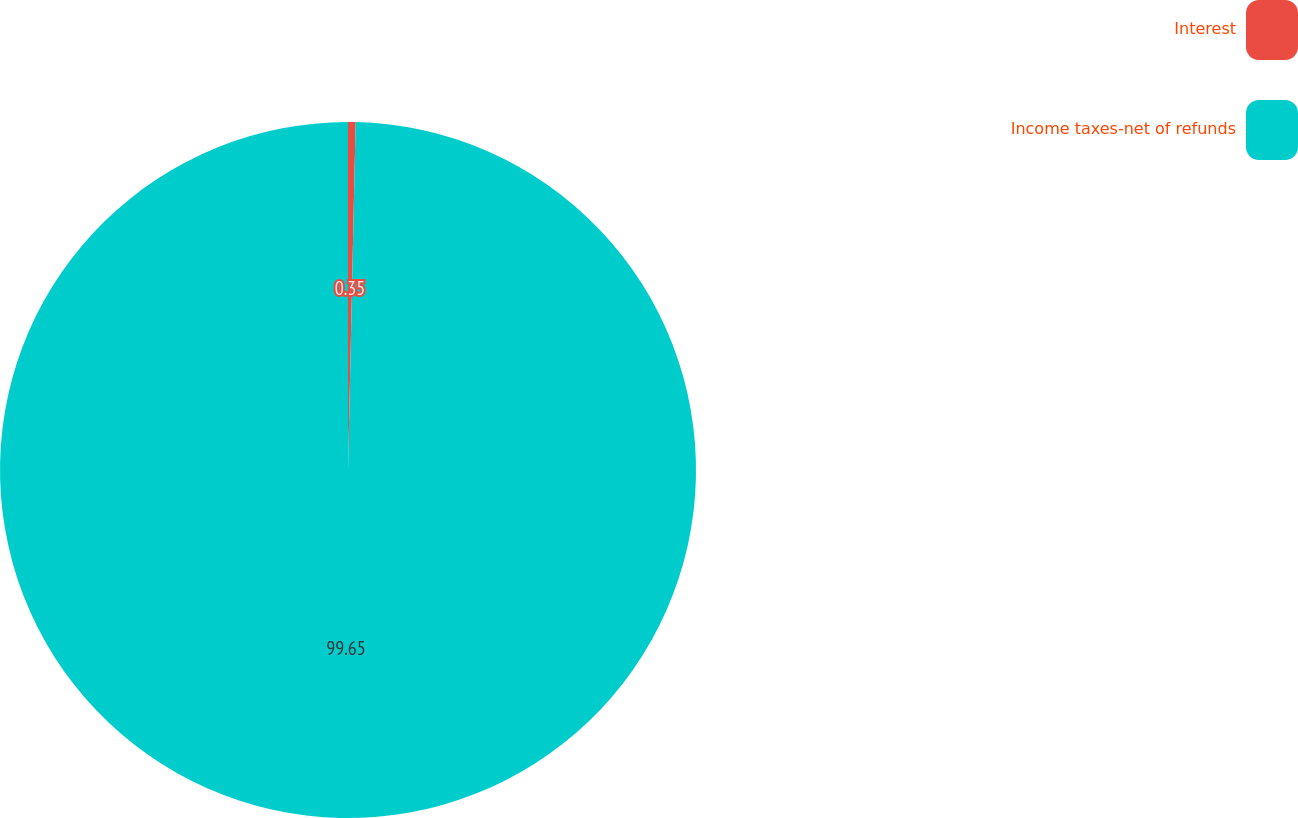Convert chart to OTSL. <chart><loc_0><loc_0><loc_500><loc_500><pie_chart><fcel>Interest<fcel>Income taxes-net of refunds<nl><fcel>0.35%<fcel>99.65%<nl></chart> 